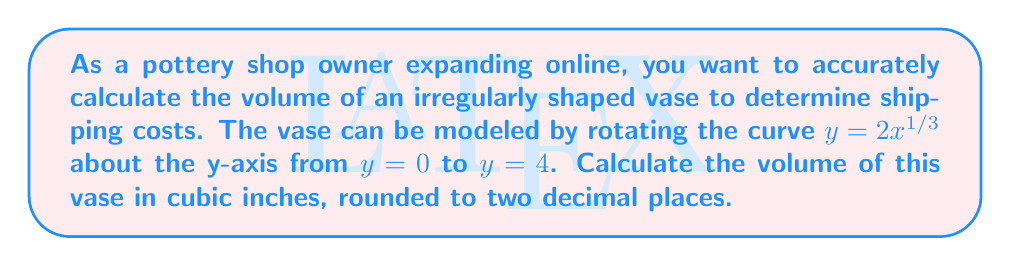Can you answer this question? To find the volume of this irregularly shaped vase, we'll use the washer method of integration, which is a technique for finding the volume of a solid of revolution.

Step 1: Identify the function and limits of integration
The curve is given by $y = 2x^{1/3}$, rotated about the y-axis.
The limits are from $y = 0$ to $y = 4$.

Step 2: Solve for x in terms of y
$y = 2x^{1/3}$
$x = (\frac{y}{2})^3$

Step 3: Set up the integral
The volume formula for a solid of revolution about the y-axis is:
$$V = \pi \int_a^b [x(y)]^2 dy$$

Substituting our function and limits:
$$V = \pi \int_0^4 [(\frac{y}{2})^3]^2 dy$$

Step 4: Simplify the integrand
$$V = \pi \int_0^4 (\frac{y}{2})^6 dy$$
$$V = \frac{\pi}{64} \int_0^4 y^6 dy$$

Step 5: Integrate
$$V = \frac{\pi}{64} [\frac{y^7}{7}]_0^4$$

Step 6: Evaluate the integral
$$V = \frac{\pi}{64} (\frac{4^7}{7} - 0)$$
$$V = \frac{\pi}{64} \cdot \frac{16384}{7}$$
$$V = \frac{256\pi}{7} \approx 114.61$$

Therefore, the volume of the vase is approximately 114.61 cubic inches.
Answer: 114.61 cubic inches 